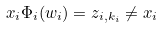<formula> <loc_0><loc_0><loc_500><loc_500>x _ { i } \Phi _ { i } ( w _ { i } ) = z _ { i , k _ { i } } \neq x _ { i }</formula> 